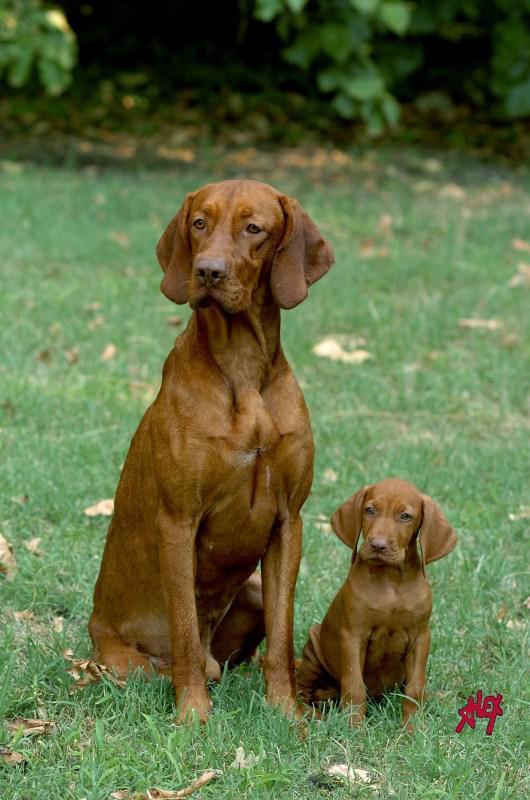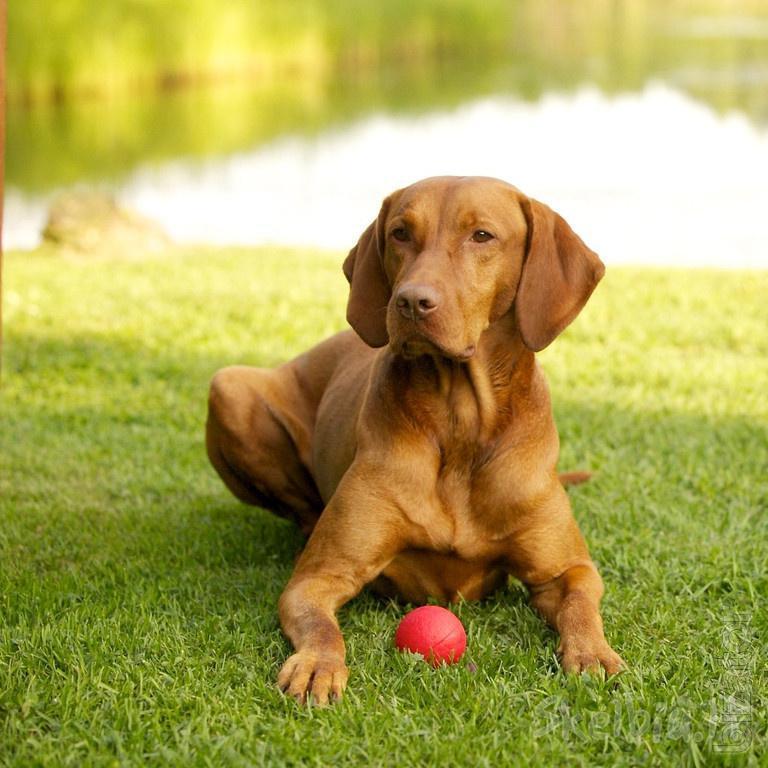The first image is the image on the left, the second image is the image on the right. Analyze the images presented: Is the assertion "The left image includes a puppy sitting upright and facing forward, and the right image contains one dog in a reclining pose on grass, with its head facing forward." valid? Answer yes or no. Yes. The first image is the image on the left, the second image is the image on the right. Given the left and right images, does the statement "A dog is sitting with one paw in front of the other paw." hold true? Answer yes or no. No. 